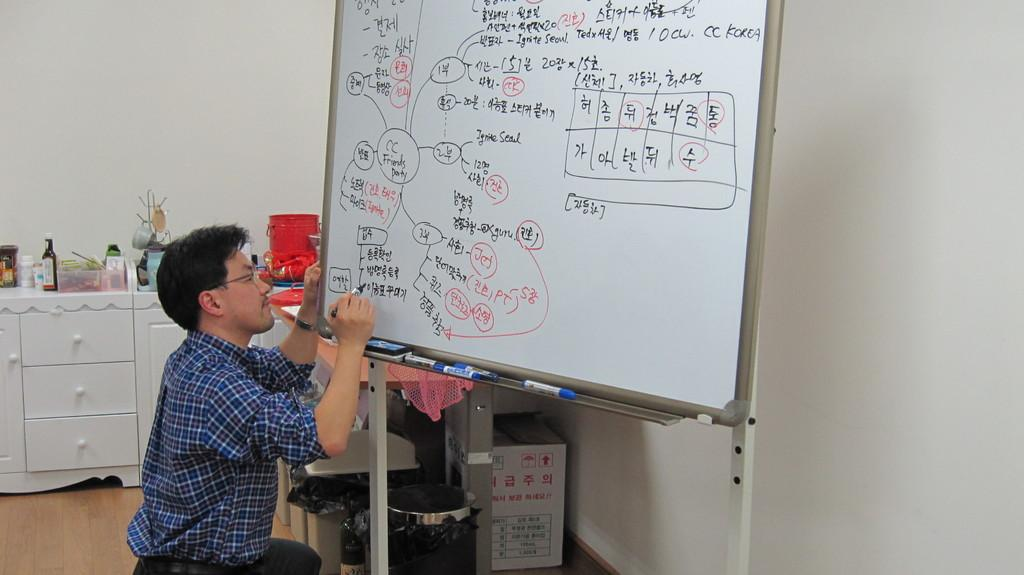<image>
Offer a succinct explanation of the picture presented. A man writing diagrams about Seoul in Korean on a dry erase board. 